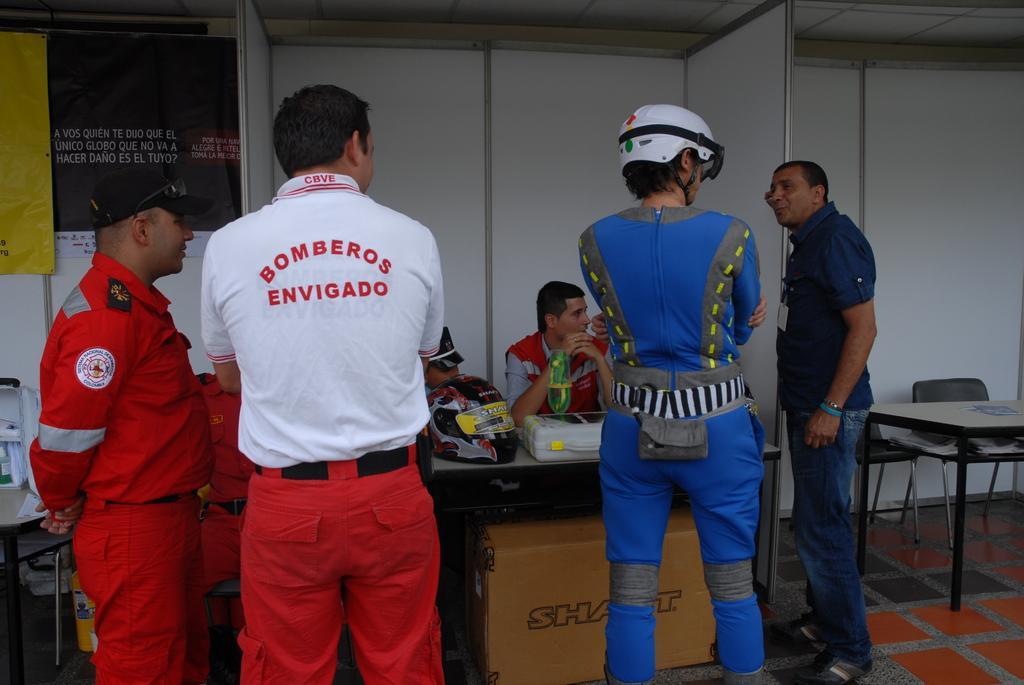In one or two sentences, can you explain what this image depicts? In this image we can see a four persons who are standing and the person on the right side is speaking. In the background we can see two persons who are sitting. This is a table where a helmet is kept on it. Here we can see a table and chair arrangement which is on the right side. 